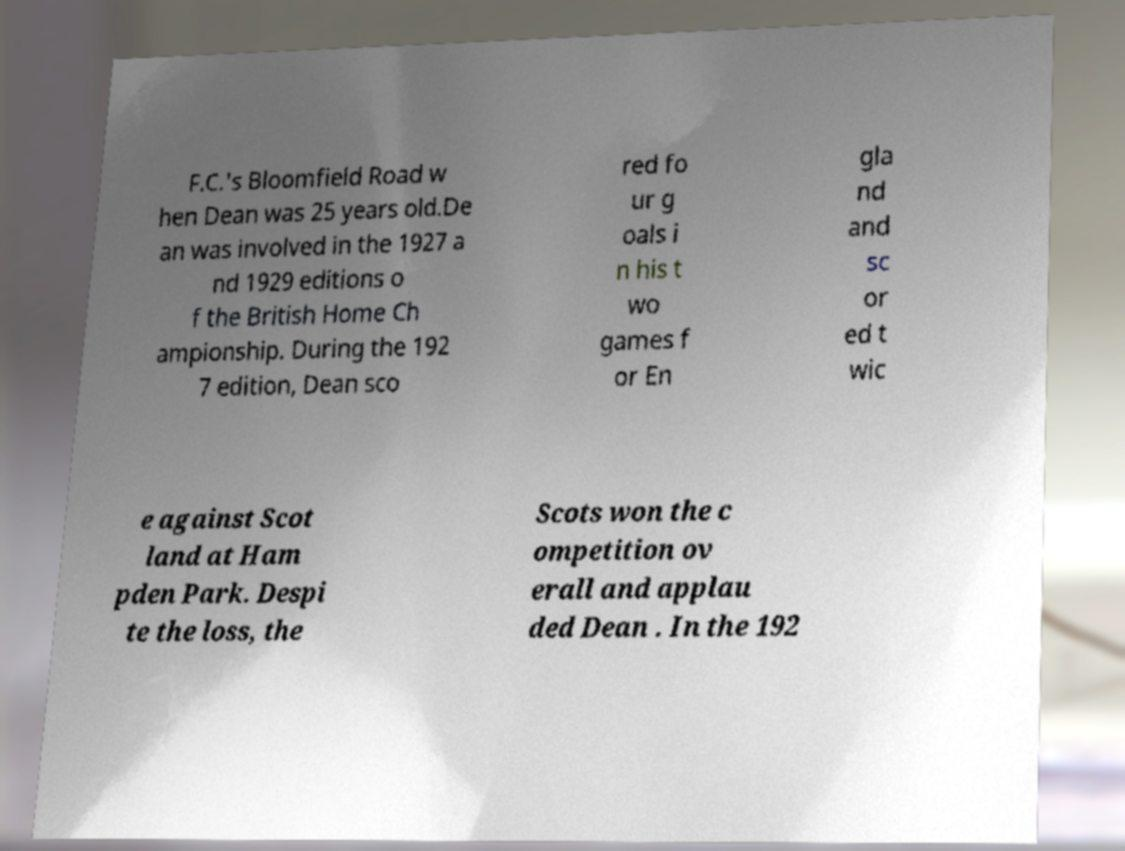Please read and relay the text visible in this image. What does it say? F.C.'s Bloomfield Road w hen Dean was 25 years old.De an was involved in the 1927 a nd 1929 editions o f the British Home Ch ampionship. During the 192 7 edition, Dean sco red fo ur g oals i n his t wo games f or En gla nd and sc or ed t wic e against Scot land at Ham pden Park. Despi te the loss, the Scots won the c ompetition ov erall and applau ded Dean . In the 192 